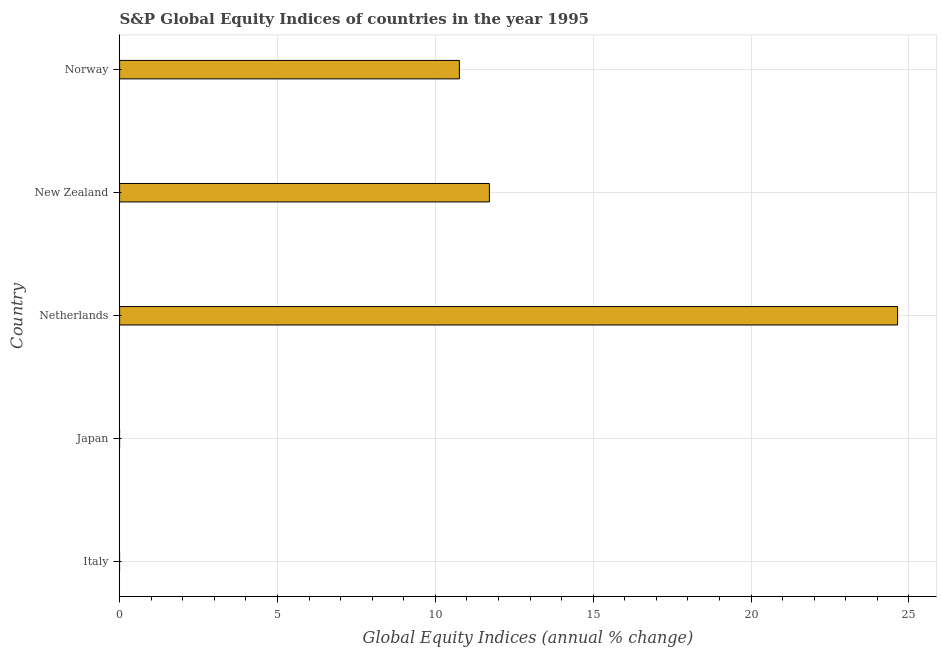Does the graph contain any zero values?
Your answer should be compact. Yes. Does the graph contain grids?
Give a very brief answer. Yes. What is the title of the graph?
Keep it short and to the point. S&P Global Equity Indices of countries in the year 1995. What is the label or title of the X-axis?
Offer a very short reply. Global Equity Indices (annual % change). What is the s&p global equity indices in Italy?
Offer a terse response. 0. Across all countries, what is the maximum s&p global equity indices?
Give a very brief answer. 24.64. In which country was the s&p global equity indices maximum?
Provide a succinct answer. Netherlands. What is the sum of the s&p global equity indices?
Your response must be concise. 47.12. What is the average s&p global equity indices per country?
Your response must be concise. 9.42. What is the median s&p global equity indices?
Make the answer very short. 10.76. In how many countries, is the s&p global equity indices greater than 3 %?
Give a very brief answer. 3. What is the ratio of the s&p global equity indices in New Zealand to that in Norway?
Keep it short and to the point. 1.09. What is the difference between the highest and the second highest s&p global equity indices?
Offer a very short reply. 12.93. What is the difference between the highest and the lowest s&p global equity indices?
Your answer should be compact. 24.64. How many countries are there in the graph?
Provide a succinct answer. 5. What is the Global Equity Indices (annual % change) of Japan?
Offer a terse response. 0. What is the Global Equity Indices (annual % change) of Netherlands?
Provide a succinct answer. 24.64. What is the Global Equity Indices (annual % change) in New Zealand?
Provide a short and direct response. 11.71. What is the Global Equity Indices (annual % change) in Norway?
Ensure brevity in your answer.  10.76. What is the difference between the Global Equity Indices (annual % change) in Netherlands and New Zealand?
Your answer should be very brief. 12.93. What is the difference between the Global Equity Indices (annual % change) in Netherlands and Norway?
Your answer should be very brief. 13.88. What is the difference between the Global Equity Indices (annual % change) in New Zealand and Norway?
Give a very brief answer. 0.95. What is the ratio of the Global Equity Indices (annual % change) in Netherlands to that in New Zealand?
Make the answer very short. 2.1. What is the ratio of the Global Equity Indices (annual % change) in Netherlands to that in Norway?
Your answer should be compact. 2.29. What is the ratio of the Global Equity Indices (annual % change) in New Zealand to that in Norway?
Provide a succinct answer. 1.09. 